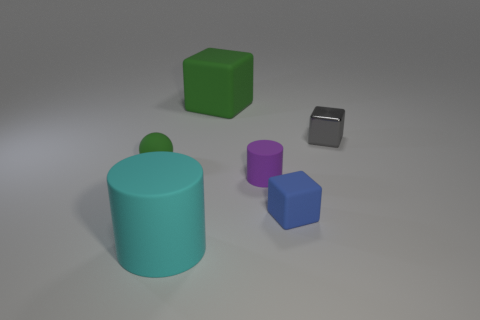Subtract all small cubes. How many cubes are left? 1 Add 1 gray shiny objects. How many objects exist? 7 Subtract all cylinders. How many objects are left? 4 Add 3 cyan rubber things. How many cyan rubber things exist? 4 Subtract 0 yellow cylinders. How many objects are left? 6 Subtract all purple balls. Subtract all red cubes. How many balls are left? 1 Subtract all large metallic cylinders. Subtract all blue blocks. How many objects are left? 5 Add 6 green matte objects. How many green matte objects are left? 8 